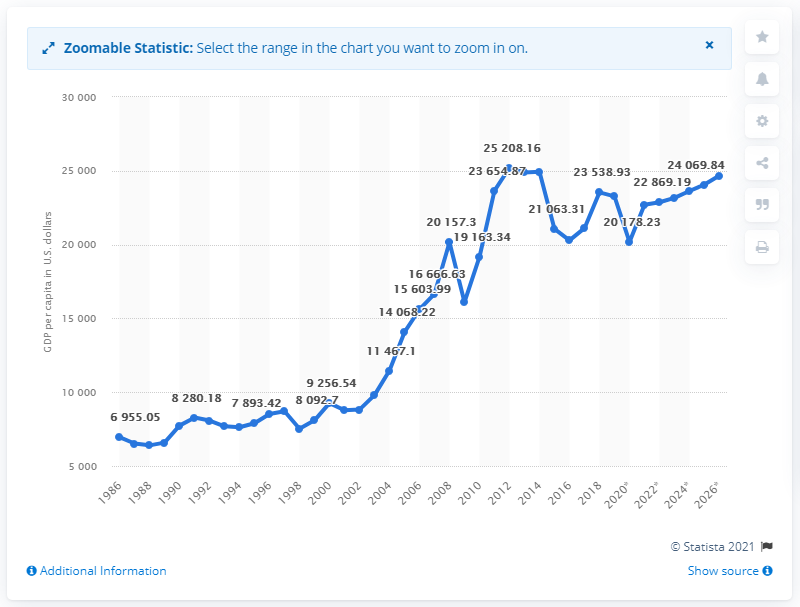Specify some key components in this picture. Saudi Arabia's per-capita GDP was calculated in 1986. 